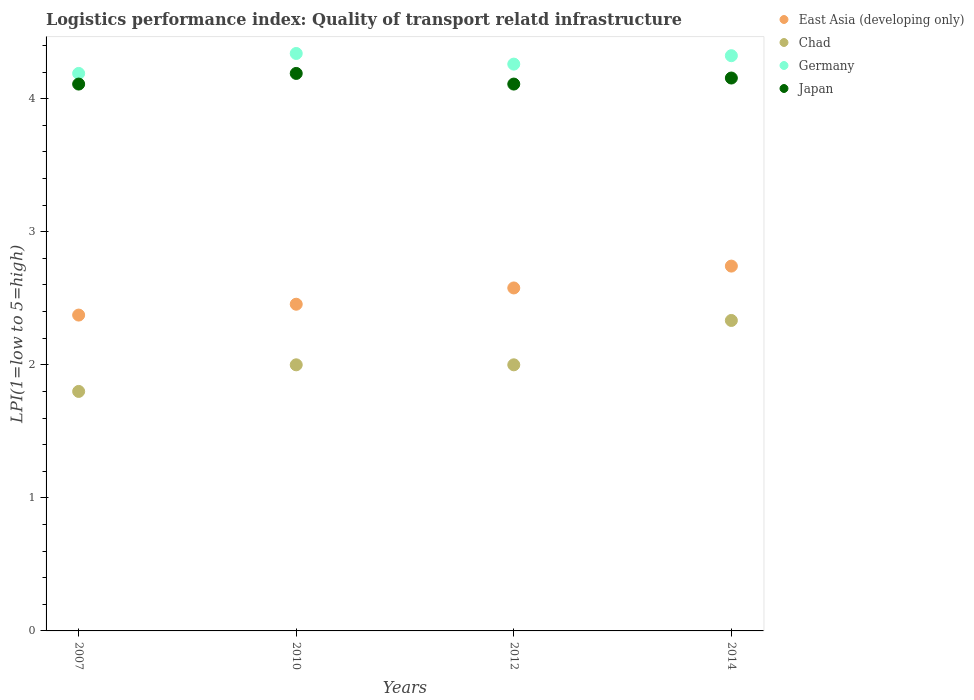How many different coloured dotlines are there?
Give a very brief answer. 4. Is the number of dotlines equal to the number of legend labels?
Offer a very short reply. Yes. What is the logistics performance index in Germany in 2014?
Your answer should be very brief. 4.32. Across all years, what is the maximum logistics performance index in Japan?
Your answer should be very brief. 4.19. Across all years, what is the minimum logistics performance index in Germany?
Offer a very short reply. 4.19. What is the total logistics performance index in East Asia (developing only) in the graph?
Keep it short and to the point. 10.15. What is the difference between the logistics performance index in Chad in 2007 and that in 2012?
Provide a short and direct response. -0.2. What is the difference between the logistics performance index in Chad in 2012 and the logistics performance index in Japan in 2010?
Offer a terse response. -2.19. What is the average logistics performance index in Japan per year?
Provide a succinct answer. 4.14. In the year 2010, what is the difference between the logistics performance index in Germany and logistics performance index in Chad?
Your response must be concise. 2.34. What is the ratio of the logistics performance index in East Asia (developing only) in 2010 to that in 2014?
Offer a terse response. 0.9. Is the difference between the logistics performance index in Germany in 2010 and 2012 greater than the difference between the logistics performance index in Chad in 2010 and 2012?
Offer a very short reply. Yes. What is the difference between the highest and the second highest logistics performance index in Germany?
Make the answer very short. 0.02. What is the difference between the highest and the lowest logistics performance index in Chad?
Provide a succinct answer. 0.53. In how many years, is the logistics performance index in East Asia (developing only) greater than the average logistics performance index in East Asia (developing only) taken over all years?
Offer a very short reply. 2. Is it the case that in every year, the sum of the logistics performance index in Japan and logistics performance index in Chad  is greater than the sum of logistics performance index in East Asia (developing only) and logistics performance index in Germany?
Provide a short and direct response. Yes. Is it the case that in every year, the sum of the logistics performance index in East Asia (developing only) and logistics performance index in Japan  is greater than the logistics performance index in Chad?
Give a very brief answer. Yes. Is the logistics performance index in Germany strictly greater than the logistics performance index in East Asia (developing only) over the years?
Keep it short and to the point. Yes. Does the graph contain grids?
Give a very brief answer. No. How are the legend labels stacked?
Ensure brevity in your answer.  Vertical. What is the title of the graph?
Your answer should be very brief. Logistics performance index: Quality of transport relatd infrastructure. What is the label or title of the Y-axis?
Make the answer very short. LPI(1=low to 5=high). What is the LPI(1=low to 5=high) in East Asia (developing only) in 2007?
Provide a short and direct response. 2.37. What is the LPI(1=low to 5=high) in Germany in 2007?
Offer a terse response. 4.19. What is the LPI(1=low to 5=high) in Japan in 2007?
Offer a terse response. 4.11. What is the LPI(1=low to 5=high) in East Asia (developing only) in 2010?
Give a very brief answer. 2.46. What is the LPI(1=low to 5=high) of Chad in 2010?
Keep it short and to the point. 2. What is the LPI(1=low to 5=high) in Germany in 2010?
Your answer should be very brief. 4.34. What is the LPI(1=low to 5=high) of Japan in 2010?
Offer a very short reply. 4.19. What is the LPI(1=low to 5=high) in East Asia (developing only) in 2012?
Offer a terse response. 2.58. What is the LPI(1=low to 5=high) in Chad in 2012?
Ensure brevity in your answer.  2. What is the LPI(1=low to 5=high) in Germany in 2012?
Offer a very short reply. 4.26. What is the LPI(1=low to 5=high) of Japan in 2012?
Your answer should be very brief. 4.11. What is the LPI(1=low to 5=high) in East Asia (developing only) in 2014?
Your response must be concise. 2.74. What is the LPI(1=low to 5=high) in Chad in 2014?
Offer a very short reply. 2.33. What is the LPI(1=low to 5=high) in Germany in 2014?
Keep it short and to the point. 4.32. What is the LPI(1=low to 5=high) of Japan in 2014?
Provide a short and direct response. 4.16. Across all years, what is the maximum LPI(1=low to 5=high) of East Asia (developing only)?
Give a very brief answer. 2.74. Across all years, what is the maximum LPI(1=low to 5=high) of Chad?
Give a very brief answer. 2.33. Across all years, what is the maximum LPI(1=low to 5=high) of Germany?
Provide a succinct answer. 4.34. Across all years, what is the maximum LPI(1=low to 5=high) of Japan?
Offer a terse response. 4.19. Across all years, what is the minimum LPI(1=low to 5=high) in East Asia (developing only)?
Provide a succinct answer. 2.37. Across all years, what is the minimum LPI(1=low to 5=high) in Germany?
Provide a succinct answer. 4.19. Across all years, what is the minimum LPI(1=low to 5=high) of Japan?
Keep it short and to the point. 4.11. What is the total LPI(1=low to 5=high) of East Asia (developing only) in the graph?
Provide a short and direct response. 10.15. What is the total LPI(1=low to 5=high) in Chad in the graph?
Keep it short and to the point. 8.13. What is the total LPI(1=low to 5=high) of Germany in the graph?
Provide a succinct answer. 17.11. What is the total LPI(1=low to 5=high) in Japan in the graph?
Make the answer very short. 16.57. What is the difference between the LPI(1=low to 5=high) of East Asia (developing only) in 2007 and that in 2010?
Provide a succinct answer. -0.08. What is the difference between the LPI(1=low to 5=high) of Japan in 2007 and that in 2010?
Your answer should be compact. -0.08. What is the difference between the LPI(1=low to 5=high) in East Asia (developing only) in 2007 and that in 2012?
Your answer should be compact. -0.2. What is the difference between the LPI(1=low to 5=high) of Chad in 2007 and that in 2012?
Provide a short and direct response. -0.2. What is the difference between the LPI(1=low to 5=high) of Germany in 2007 and that in 2012?
Provide a short and direct response. -0.07. What is the difference between the LPI(1=low to 5=high) of Japan in 2007 and that in 2012?
Your response must be concise. 0. What is the difference between the LPI(1=low to 5=high) of East Asia (developing only) in 2007 and that in 2014?
Make the answer very short. -0.37. What is the difference between the LPI(1=low to 5=high) in Chad in 2007 and that in 2014?
Provide a succinct answer. -0.53. What is the difference between the LPI(1=low to 5=high) of Germany in 2007 and that in 2014?
Offer a terse response. -0.13. What is the difference between the LPI(1=low to 5=high) in Japan in 2007 and that in 2014?
Offer a very short reply. -0.05. What is the difference between the LPI(1=low to 5=high) of East Asia (developing only) in 2010 and that in 2012?
Ensure brevity in your answer.  -0.12. What is the difference between the LPI(1=low to 5=high) in East Asia (developing only) in 2010 and that in 2014?
Provide a short and direct response. -0.29. What is the difference between the LPI(1=low to 5=high) of Chad in 2010 and that in 2014?
Your answer should be very brief. -0.33. What is the difference between the LPI(1=low to 5=high) of Germany in 2010 and that in 2014?
Give a very brief answer. 0.02. What is the difference between the LPI(1=low to 5=high) in Japan in 2010 and that in 2014?
Provide a short and direct response. 0.03. What is the difference between the LPI(1=low to 5=high) of East Asia (developing only) in 2012 and that in 2014?
Keep it short and to the point. -0.16. What is the difference between the LPI(1=low to 5=high) in Chad in 2012 and that in 2014?
Give a very brief answer. -0.33. What is the difference between the LPI(1=low to 5=high) of Germany in 2012 and that in 2014?
Ensure brevity in your answer.  -0.06. What is the difference between the LPI(1=low to 5=high) of Japan in 2012 and that in 2014?
Keep it short and to the point. -0.05. What is the difference between the LPI(1=low to 5=high) of East Asia (developing only) in 2007 and the LPI(1=low to 5=high) of Chad in 2010?
Ensure brevity in your answer.  0.37. What is the difference between the LPI(1=low to 5=high) in East Asia (developing only) in 2007 and the LPI(1=low to 5=high) in Germany in 2010?
Offer a very short reply. -1.97. What is the difference between the LPI(1=low to 5=high) of East Asia (developing only) in 2007 and the LPI(1=low to 5=high) of Japan in 2010?
Your response must be concise. -1.82. What is the difference between the LPI(1=low to 5=high) in Chad in 2007 and the LPI(1=low to 5=high) in Germany in 2010?
Give a very brief answer. -2.54. What is the difference between the LPI(1=low to 5=high) in Chad in 2007 and the LPI(1=low to 5=high) in Japan in 2010?
Your answer should be compact. -2.39. What is the difference between the LPI(1=low to 5=high) in East Asia (developing only) in 2007 and the LPI(1=low to 5=high) in Chad in 2012?
Ensure brevity in your answer.  0.37. What is the difference between the LPI(1=low to 5=high) of East Asia (developing only) in 2007 and the LPI(1=low to 5=high) of Germany in 2012?
Ensure brevity in your answer.  -1.89. What is the difference between the LPI(1=low to 5=high) in East Asia (developing only) in 2007 and the LPI(1=low to 5=high) in Japan in 2012?
Ensure brevity in your answer.  -1.74. What is the difference between the LPI(1=low to 5=high) of Chad in 2007 and the LPI(1=low to 5=high) of Germany in 2012?
Make the answer very short. -2.46. What is the difference between the LPI(1=low to 5=high) in Chad in 2007 and the LPI(1=low to 5=high) in Japan in 2012?
Offer a very short reply. -2.31. What is the difference between the LPI(1=low to 5=high) in East Asia (developing only) in 2007 and the LPI(1=low to 5=high) in Chad in 2014?
Ensure brevity in your answer.  0.04. What is the difference between the LPI(1=low to 5=high) in East Asia (developing only) in 2007 and the LPI(1=low to 5=high) in Germany in 2014?
Your answer should be very brief. -1.95. What is the difference between the LPI(1=low to 5=high) in East Asia (developing only) in 2007 and the LPI(1=low to 5=high) in Japan in 2014?
Provide a short and direct response. -1.78. What is the difference between the LPI(1=low to 5=high) of Chad in 2007 and the LPI(1=low to 5=high) of Germany in 2014?
Your response must be concise. -2.52. What is the difference between the LPI(1=low to 5=high) in Chad in 2007 and the LPI(1=low to 5=high) in Japan in 2014?
Provide a short and direct response. -2.36. What is the difference between the LPI(1=low to 5=high) in Germany in 2007 and the LPI(1=low to 5=high) in Japan in 2014?
Provide a succinct answer. 0.03. What is the difference between the LPI(1=low to 5=high) of East Asia (developing only) in 2010 and the LPI(1=low to 5=high) of Chad in 2012?
Your response must be concise. 0.46. What is the difference between the LPI(1=low to 5=high) in East Asia (developing only) in 2010 and the LPI(1=low to 5=high) in Germany in 2012?
Offer a terse response. -1.8. What is the difference between the LPI(1=low to 5=high) of East Asia (developing only) in 2010 and the LPI(1=low to 5=high) of Japan in 2012?
Your answer should be very brief. -1.65. What is the difference between the LPI(1=low to 5=high) of Chad in 2010 and the LPI(1=low to 5=high) of Germany in 2012?
Your response must be concise. -2.26. What is the difference between the LPI(1=low to 5=high) of Chad in 2010 and the LPI(1=low to 5=high) of Japan in 2012?
Offer a terse response. -2.11. What is the difference between the LPI(1=low to 5=high) of Germany in 2010 and the LPI(1=low to 5=high) of Japan in 2012?
Ensure brevity in your answer.  0.23. What is the difference between the LPI(1=low to 5=high) in East Asia (developing only) in 2010 and the LPI(1=low to 5=high) in Chad in 2014?
Provide a succinct answer. 0.12. What is the difference between the LPI(1=low to 5=high) of East Asia (developing only) in 2010 and the LPI(1=low to 5=high) of Germany in 2014?
Your answer should be very brief. -1.87. What is the difference between the LPI(1=low to 5=high) in Chad in 2010 and the LPI(1=low to 5=high) in Germany in 2014?
Your response must be concise. -2.32. What is the difference between the LPI(1=low to 5=high) of Chad in 2010 and the LPI(1=low to 5=high) of Japan in 2014?
Your response must be concise. -2.16. What is the difference between the LPI(1=low to 5=high) in Germany in 2010 and the LPI(1=low to 5=high) in Japan in 2014?
Offer a terse response. 0.18. What is the difference between the LPI(1=low to 5=high) of East Asia (developing only) in 2012 and the LPI(1=low to 5=high) of Chad in 2014?
Give a very brief answer. 0.24. What is the difference between the LPI(1=low to 5=high) in East Asia (developing only) in 2012 and the LPI(1=low to 5=high) in Germany in 2014?
Keep it short and to the point. -1.75. What is the difference between the LPI(1=low to 5=high) of East Asia (developing only) in 2012 and the LPI(1=low to 5=high) of Japan in 2014?
Give a very brief answer. -1.58. What is the difference between the LPI(1=low to 5=high) of Chad in 2012 and the LPI(1=low to 5=high) of Germany in 2014?
Ensure brevity in your answer.  -2.32. What is the difference between the LPI(1=low to 5=high) of Chad in 2012 and the LPI(1=low to 5=high) of Japan in 2014?
Offer a terse response. -2.16. What is the difference between the LPI(1=low to 5=high) in Germany in 2012 and the LPI(1=low to 5=high) in Japan in 2014?
Your answer should be very brief. 0.1. What is the average LPI(1=low to 5=high) in East Asia (developing only) per year?
Provide a succinct answer. 2.54. What is the average LPI(1=low to 5=high) of Chad per year?
Provide a short and direct response. 2.03. What is the average LPI(1=low to 5=high) in Germany per year?
Keep it short and to the point. 4.28. What is the average LPI(1=low to 5=high) in Japan per year?
Your answer should be very brief. 4.14. In the year 2007, what is the difference between the LPI(1=low to 5=high) in East Asia (developing only) and LPI(1=low to 5=high) in Chad?
Your answer should be very brief. 0.57. In the year 2007, what is the difference between the LPI(1=low to 5=high) of East Asia (developing only) and LPI(1=low to 5=high) of Germany?
Offer a very short reply. -1.82. In the year 2007, what is the difference between the LPI(1=low to 5=high) in East Asia (developing only) and LPI(1=low to 5=high) in Japan?
Offer a very short reply. -1.74. In the year 2007, what is the difference between the LPI(1=low to 5=high) in Chad and LPI(1=low to 5=high) in Germany?
Provide a short and direct response. -2.39. In the year 2007, what is the difference between the LPI(1=low to 5=high) in Chad and LPI(1=low to 5=high) in Japan?
Offer a terse response. -2.31. In the year 2010, what is the difference between the LPI(1=low to 5=high) of East Asia (developing only) and LPI(1=low to 5=high) of Chad?
Keep it short and to the point. 0.46. In the year 2010, what is the difference between the LPI(1=low to 5=high) in East Asia (developing only) and LPI(1=low to 5=high) in Germany?
Your answer should be compact. -1.88. In the year 2010, what is the difference between the LPI(1=low to 5=high) of East Asia (developing only) and LPI(1=low to 5=high) of Japan?
Offer a very short reply. -1.73. In the year 2010, what is the difference between the LPI(1=low to 5=high) in Chad and LPI(1=low to 5=high) in Germany?
Offer a terse response. -2.34. In the year 2010, what is the difference between the LPI(1=low to 5=high) of Chad and LPI(1=low to 5=high) of Japan?
Keep it short and to the point. -2.19. In the year 2010, what is the difference between the LPI(1=low to 5=high) in Germany and LPI(1=low to 5=high) in Japan?
Keep it short and to the point. 0.15. In the year 2012, what is the difference between the LPI(1=low to 5=high) of East Asia (developing only) and LPI(1=low to 5=high) of Chad?
Provide a succinct answer. 0.58. In the year 2012, what is the difference between the LPI(1=low to 5=high) in East Asia (developing only) and LPI(1=low to 5=high) in Germany?
Give a very brief answer. -1.68. In the year 2012, what is the difference between the LPI(1=low to 5=high) in East Asia (developing only) and LPI(1=low to 5=high) in Japan?
Offer a very short reply. -1.53. In the year 2012, what is the difference between the LPI(1=low to 5=high) of Chad and LPI(1=low to 5=high) of Germany?
Your response must be concise. -2.26. In the year 2012, what is the difference between the LPI(1=low to 5=high) in Chad and LPI(1=low to 5=high) in Japan?
Keep it short and to the point. -2.11. In the year 2014, what is the difference between the LPI(1=low to 5=high) in East Asia (developing only) and LPI(1=low to 5=high) in Chad?
Keep it short and to the point. 0.41. In the year 2014, what is the difference between the LPI(1=low to 5=high) of East Asia (developing only) and LPI(1=low to 5=high) of Germany?
Keep it short and to the point. -1.58. In the year 2014, what is the difference between the LPI(1=low to 5=high) of East Asia (developing only) and LPI(1=low to 5=high) of Japan?
Offer a terse response. -1.41. In the year 2014, what is the difference between the LPI(1=low to 5=high) in Chad and LPI(1=low to 5=high) in Germany?
Offer a very short reply. -1.99. In the year 2014, what is the difference between the LPI(1=low to 5=high) in Chad and LPI(1=low to 5=high) in Japan?
Your response must be concise. -1.82. In the year 2014, what is the difference between the LPI(1=low to 5=high) of Germany and LPI(1=low to 5=high) of Japan?
Provide a succinct answer. 0.17. What is the ratio of the LPI(1=low to 5=high) of East Asia (developing only) in 2007 to that in 2010?
Provide a succinct answer. 0.97. What is the ratio of the LPI(1=low to 5=high) of Chad in 2007 to that in 2010?
Provide a succinct answer. 0.9. What is the ratio of the LPI(1=low to 5=high) in Germany in 2007 to that in 2010?
Provide a short and direct response. 0.97. What is the ratio of the LPI(1=low to 5=high) in Japan in 2007 to that in 2010?
Give a very brief answer. 0.98. What is the ratio of the LPI(1=low to 5=high) in East Asia (developing only) in 2007 to that in 2012?
Ensure brevity in your answer.  0.92. What is the ratio of the LPI(1=low to 5=high) in Chad in 2007 to that in 2012?
Provide a short and direct response. 0.9. What is the ratio of the LPI(1=low to 5=high) in Germany in 2007 to that in 2012?
Provide a succinct answer. 0.98. What is the ratio of the LPI(1=low to 5=high) in Japan in 2007 to that in 2012?
Offer a terse response. 1. What is the ratio of the LPI(1=low to 5=high) in East Asia (developing only) in 2007 to that in 2014?
Provide a succinct answer. 0.87. What is the ratio of the LPI(1=low to 5=high) of Chad in 2007 to that in 2014?
Provide a succinct answer. 0.77. What is the ratio of the LPI(1=low to 5=high) in Germany in 2007 to that in 2014?
Provide a short and direct response. 0.97. What is the ratio of the LPI(1=low to 5=high) of East Asia (developing only) in 2010 to that in 2012?
Make the answer very short. 0.95. What is the ratio of the LPI(1=low to 5=high) of Germany in 2010 to that in 2012?
Provide a short and direct response. 1.02. What is the ratio of the LPI(1=low to 5=high) in Japan in 2010 to that in 2012?
Ensure brevity in your answer.  1.02. What is the ratio of the LPI(1=low to 5=high) in East Asia (developing only) in 2010 to that in 2014?
Your answer should be very brief. 0.9. What is the ratio of the LPI(1=low to 5=high) of Chad in 2010 to that in 2014?
Give a very brief answer. 0.86. What is the ratio of the LPI(1=low to 5=high) in Germany in 2010 to that in 2014?
Your answer should be compact. 1. What is the ratio of the LPI(1=low to 5=high) in Japan in 2010 to that in 2014?
Offer a very short reply. 1.01. What is the ratio of the LPI(1=low to 5=high) of East Asia (developing only) in 2012 to that in 2014?
Keep it short and to the point. 0.94. What is the ratio of the LPI(1=low to 5=high) in Germany in 2012 to that in 2014?
Keep it short and to the point. 0.99. What is the difference between the highest and the second highest LPI(1=low to 5=high) of East Asia (developing only)?
Your answer should be very brief. 0.16. What is the difference between the highest and the second highest LPI(1=low to 5=high) of Chad?
Provide a succinct answer. 0.33. What is the difference between the highest and the second highest LPI(1=low to 5=high) of Germany?
Provide a short and direct response. 0.02. What is the difference between the highest and the second highest LPI(1=low to 5=high) of Japan?
Provide a succinct answer. 0.03. What is the difference between the highest and the lowest LPI(1=low to 5=high) in East Asia (developing only)?
Ensure brevity in your answer.  0.37. What is the difference between the highest and the lowest LPI(1=low to 5=high) of Chad?
Provide a short and direct response. 0.53. What is the difference between the highest and the lowest LPI(1=low to 5=high) in Germany?
Ensure brevity in your answer.  0.15. 